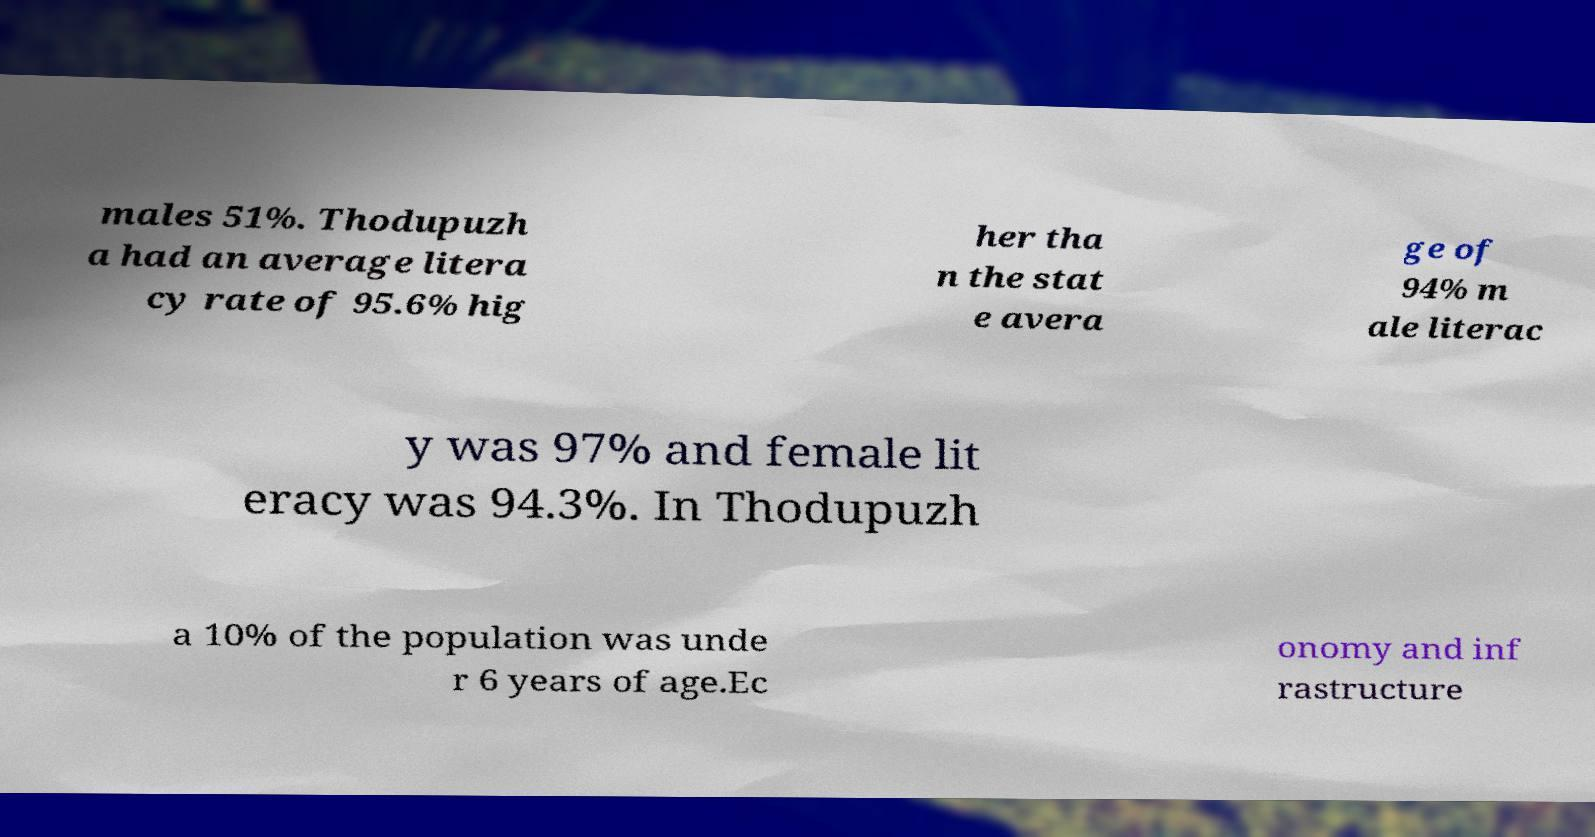Could you extract and type out the text from this image? males 51%. Thodupuzh a had an average litera cy rate of 95.6% hig her tha n the stat e avera ge of 94% m ale literac y was 97% and female lit eracy was 94.3%. In Thodupuzh a 10% of the population was unde r 6 years of age.Ec onomy and inf rastructure 